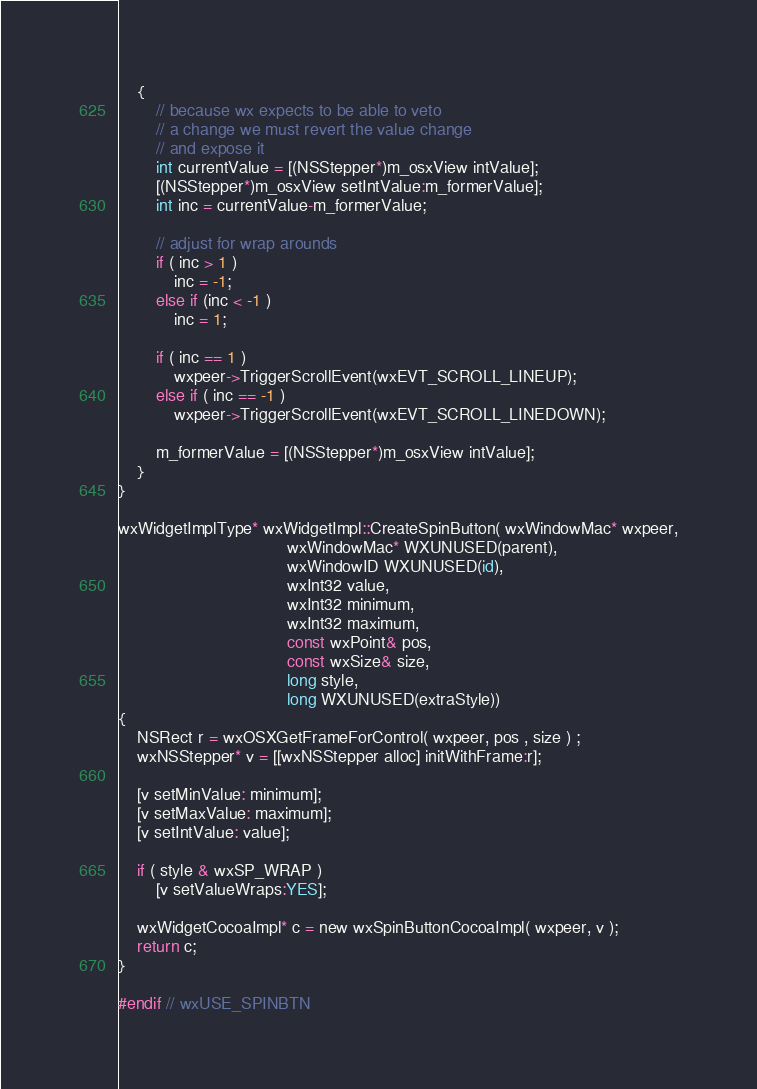Convert code to text. <code><loc_0><loc_0><loc_500><loc_500><_ObjectiveC_>    {
        // because wx expects to be able to veto
        // a change we must revert the value change
        // and expose it
        int currentValue = [(NSStepper*)m_osxView intValue];
        [(NSStepper*)m_osxView setIntValue:m_formerValue];
        int inc = currentValue-m_formerValue;

        // adjust for wrap arounds
        if ( inc > 1 )
            inc = -1;
        else if (inc < -1 )
            inc = 1;

        if ( inc == 1 )
            wxpeer->TriggerScrollEvent(wxEVT_SCROLL_LINEUP);
        else if ( inc == -1 )
            wxpeer->TriggerScrollEvent(wxEVT_SCROLL_LINEDOWN);

        m_formerValue = [(NSStepper*)m_osxView intValue];
    }
}

wxWidgetImplType* wxWidgetImpl::CreateSpinButton( wxWindowMac* wxpeer,
                                    wxWindowMac* WXUNUSED(parent),
                                    wxWindowID WXUNUSED(id),
                                    wxInt32 value,
                                    wxInt32 minimum,
                                    wxInt32 maximum,
                                    const wxPoint& pos,
                                    const wxSize& size,
                                    long style,
                                    long WXUNUSED(extraStyle))
{
    NSRect r = wxOSXGetFrameForControl( wxpeer, pos , size ) ;
    wxNSStepper* v = [[wxNSStepper alloc] initWithFrame:r];

    [v setMinValue: minimum];
    [v setMaxValue: maximum];
    [v setIntValue: value];

    if ( style & wxSP_WRAP )
        [v setValueWraps:YES];

    wxWidgetCocoaImpl* c = new wxSpinButtonCocoaImpl( wxpeer, v );
    return c;
}

#endif // wxUSE_SPINBTN
</code> 